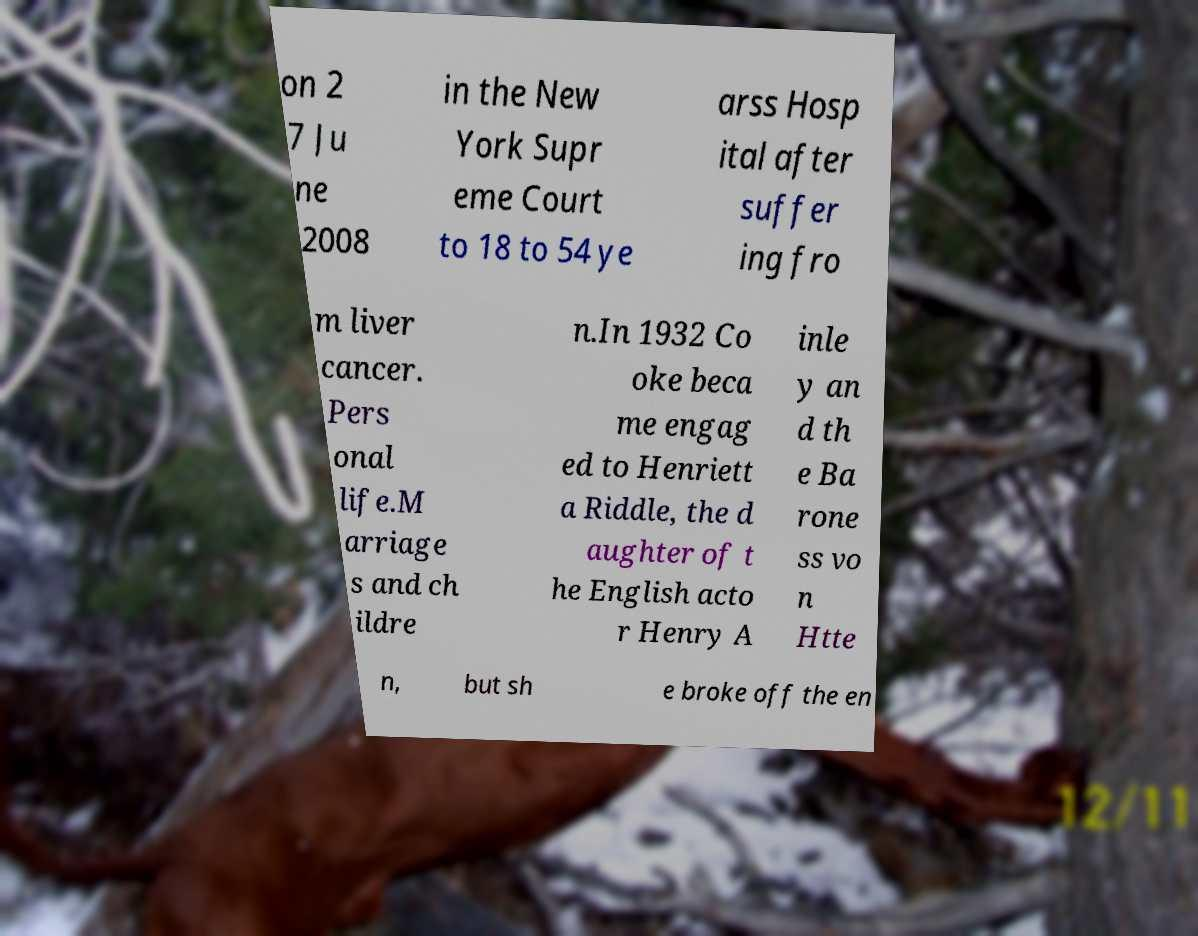I need the written content from this picture converted into text. Can you do that? on 2 7 Ju ne 2008 in the New York Supr eme Court to 18 to 54 ye arss Hosp ital after suffer ing fro m liver cancer. Pers onal life.M arriage s and ch ildre n.In 1932 Co oke beca me engag ed to Henriett a Riddle, the d aughter of t he English acto r Henry A inle y an d th e Ba rone ss vo n Htte n, but sh e broke off the en 